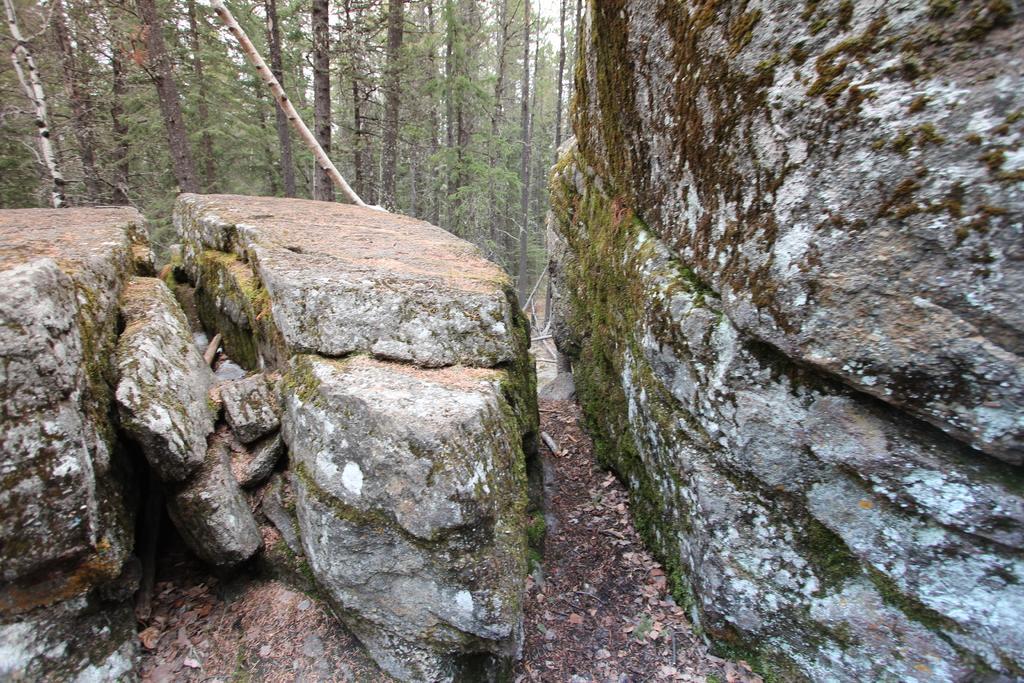Describe this image in one or two sentences. On the left side, there are rocks on a hill. On the right side, there are rocks on the ground. In the background, there are trees on the ground and there is sky. 